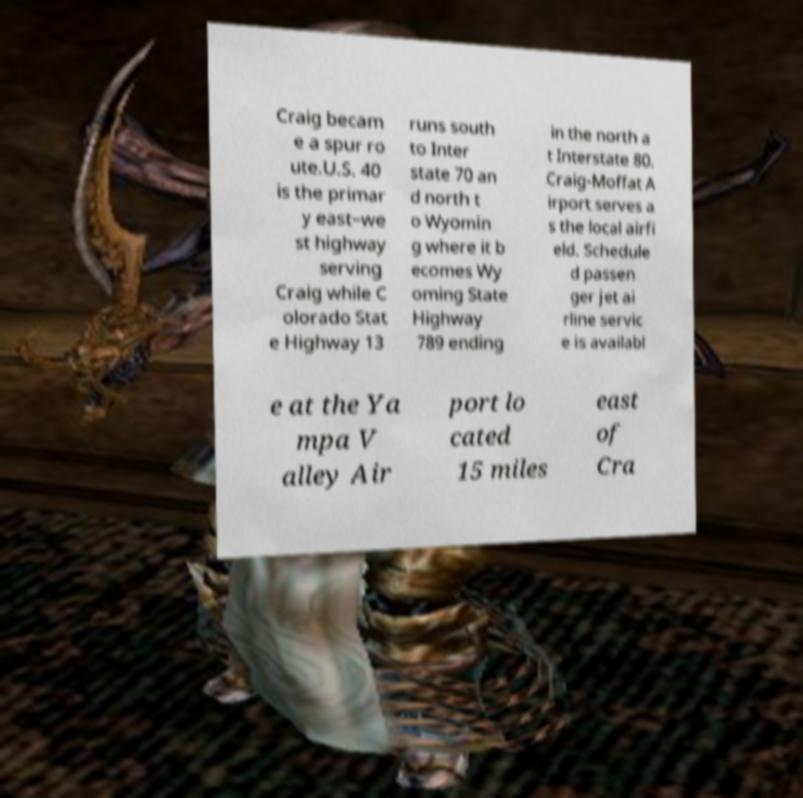I need the written content from this picture converted into text. Can you do that? Craig becam e a spur ro ute.U.S. 40 is the primar y east–we st highway serving Craig while C olorado Stat e Highway 13 runs south to Inter state 70 an d north t o Wyomin g where it b ecomes Wy oming State Highway 789 ending in the north a t Interstate 80. Craig-Moffat A irport serves a s the local airfi eld. Schedule d passen ger jet ai rline servic e is availabl e at the Ya mpa V alley Air port lo cated 15 miles east of Cra 